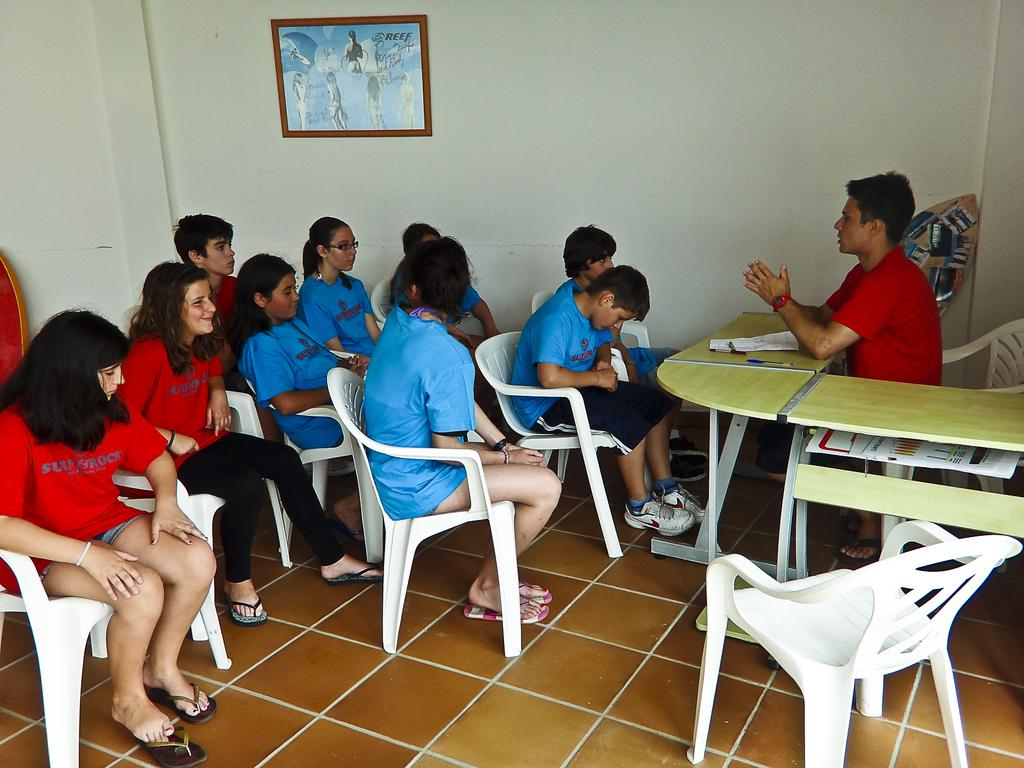What is happening in the image involving a group of people? There is a group of people in the image, and one person is explaining something to them. How are the people in the group positioned? The people in the group are sitting on chairs. What is the position of the person explaining to the group? The person explaining is also sitting on a chair. What is in front of the person explaining? There is a table in front of the person explaining. What can be seen on the wall in the image? There is a frame on the wall in the image. How many trees are visible in the image? There are no trees visible in the image. What type of rabbit can be seen hopping around the table in the image? There is no rabbit present in the image. 